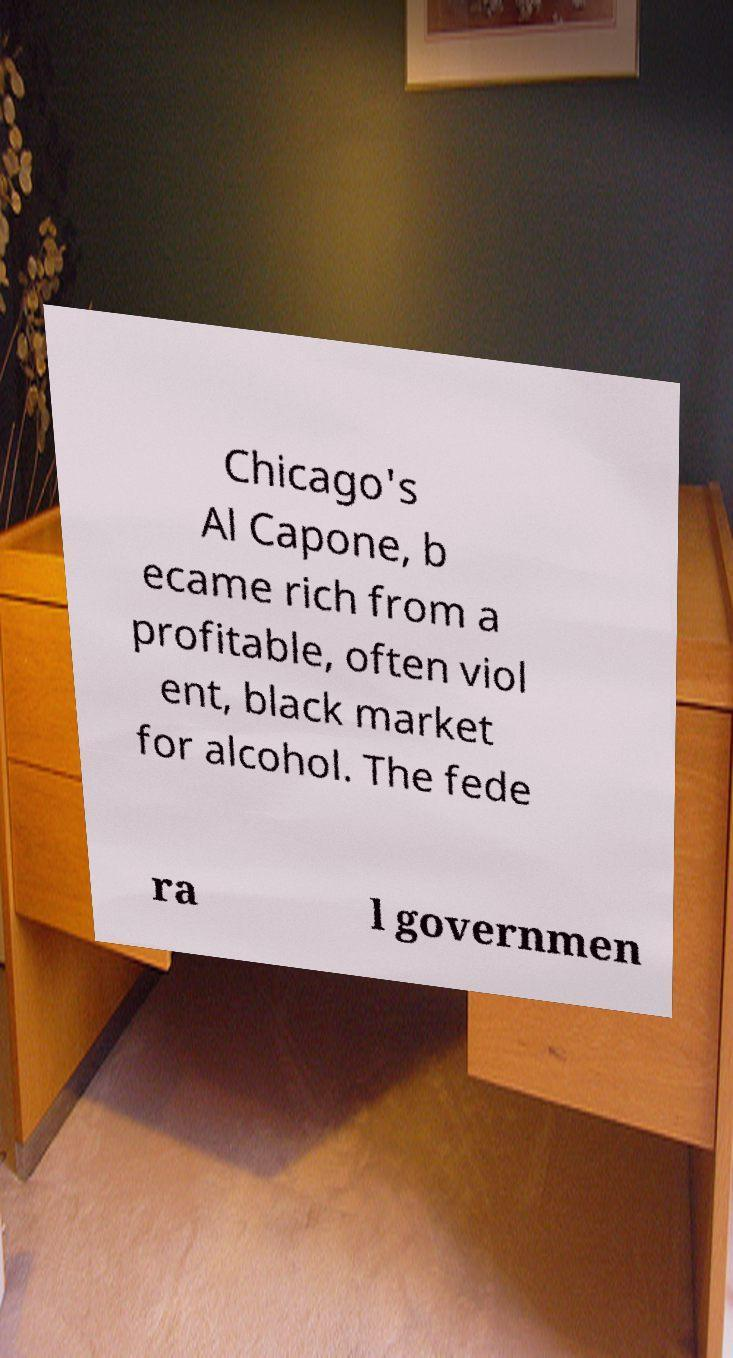Can you accurately transcribe the text from the provided image for me? Chicago's Al Capone, b ecame rich from a profitable, often viol ent, black market for alcohol. The fede ra l governmen 